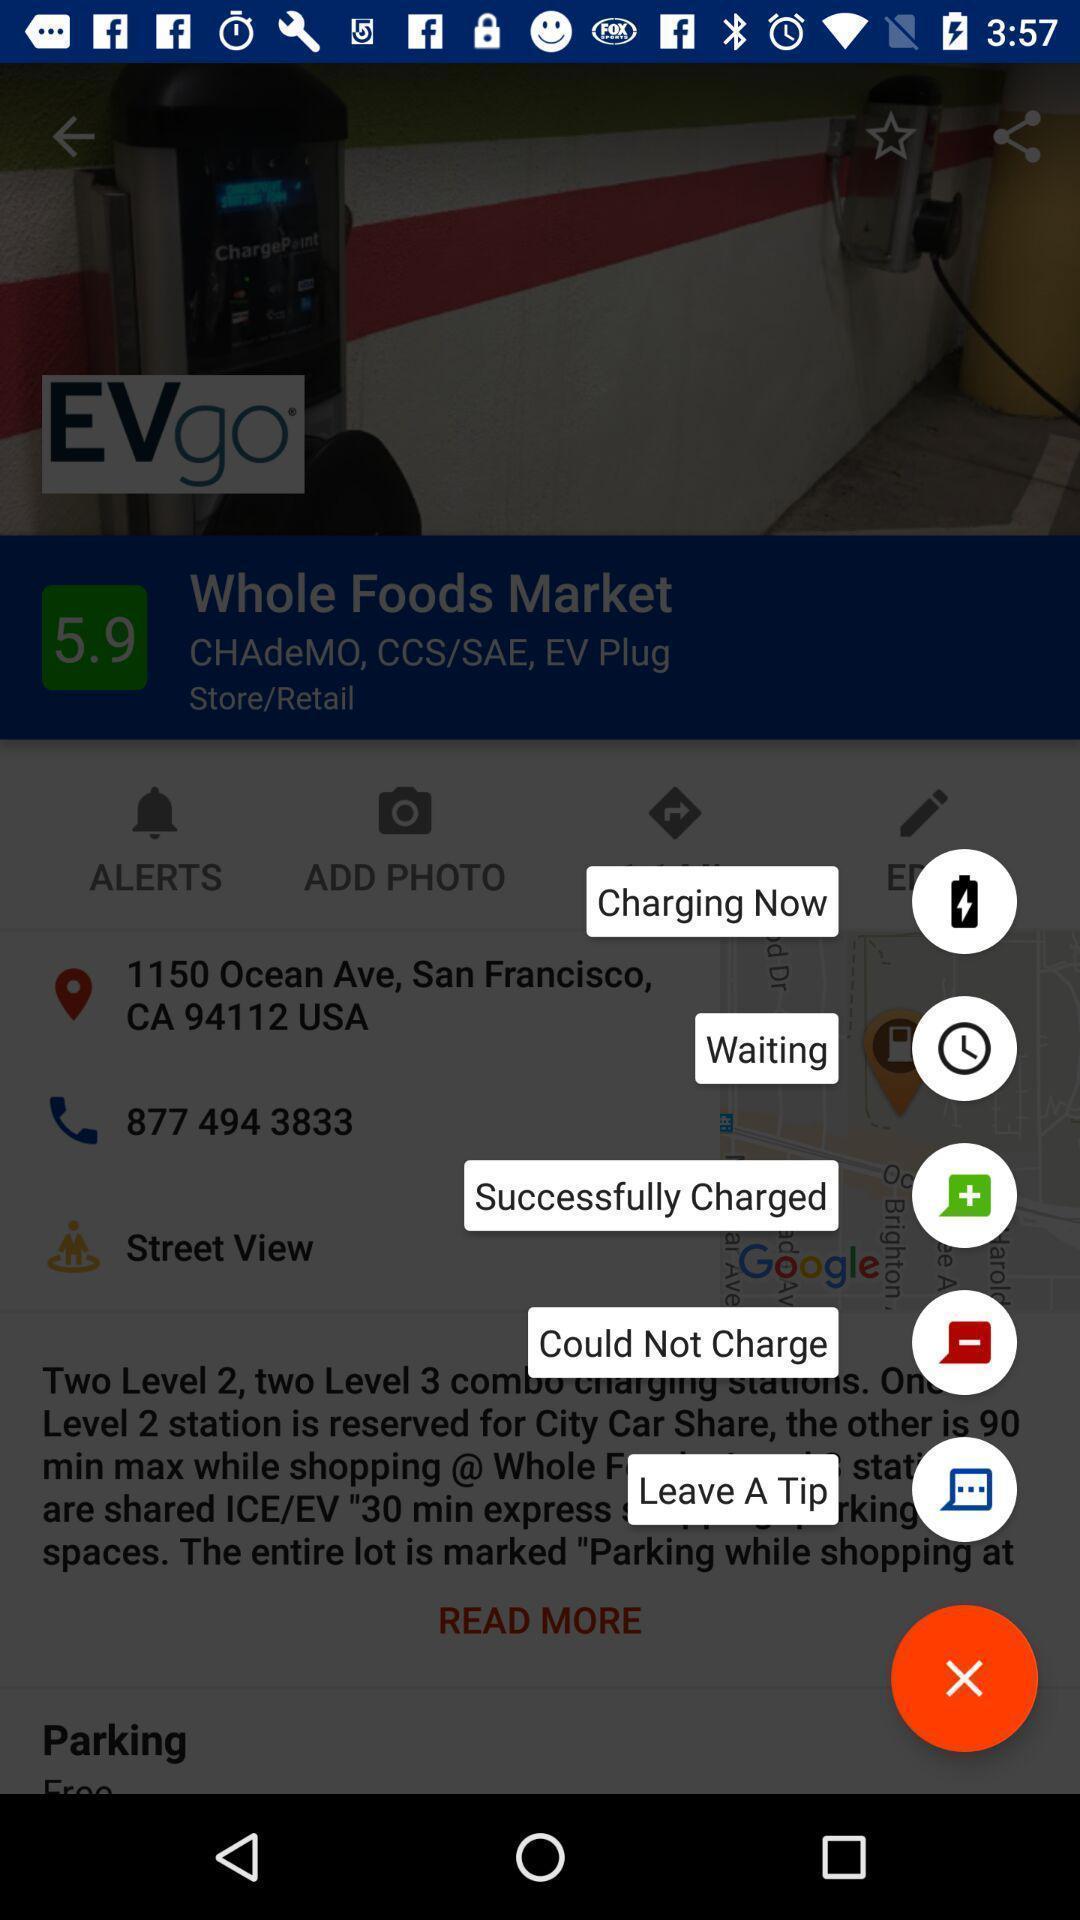Tell me about the visual elements in this screen capture. Pop-up screen displaying with few features. 